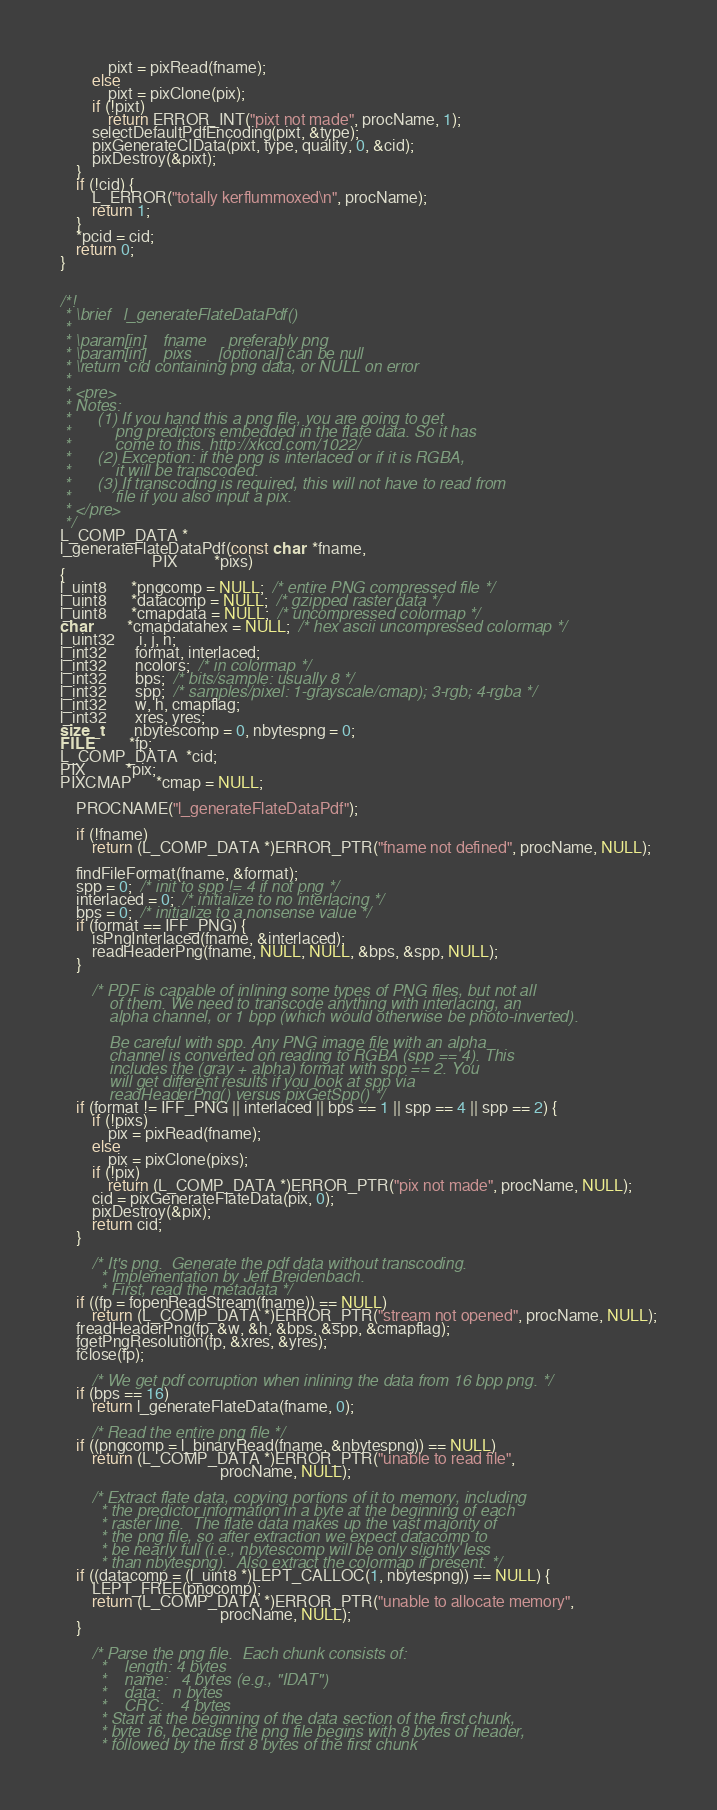Convert code to text. <code><loc_0><loc_0><loc_500><loc_500><_C_>            pixt = pixRead(fname);
        else
            pixt = pixClone(pix);
        if (!pixt)
            return ERROR_INT("pixt not made", procName, 1);
        selectDefaultPdfEncoding(pixt, &type);
        pixGenerateCIData(pixt, type, quality, 0, &cid);
        pixDestroy(&pixt);
    }
    if (!cid) {
        L_ERROR("totally kerflummoxed\n", procName);
        return 1;
    }
    *pcid = cid;
    return 0;
}


/*!
 * \brief   l_generateFlateDataPdf()
 *
 * \param[in]    fname     preferably png
 * \param[in]    pixs      [optional] can be null
 * \return  cid containing png data, or NULL on error
 *
 * <pre>
 * Notes:
 *      (1) If you hand this a png file, you are going to get
 *          png predictors embedded in the flate data. So it has
 *          come to this. http://xkcd.com/1022/
 *      (2) Exception: if the png is interlaced or if it is RGBA,
 *          it will be transcoded.
 *      (3) If transcoding is required, this will not have to read from
 *          file if you also input a pix.
 * </pre>
 */
L_COMP_DATA *
l_generateFlateDataPdf(const char  *fname,
                       PIX         *pixs)
{
l_uint8      *pngcomp = NULL;  /* entire PNG compressed file */
l_uint8      *datacomp = NULL;  /* gzipped raster data */
l_uint8      *cmapdata = NULL;  /* uncompressed colormap */
char         *cmapdatahex = NULL;  /* hex ascii uncompressed colormap */
l_uint32      i, j, n;
l_int32       format, interlaced;
l_int32       ncolors;  /* in colormap */
l_int32       bps;  /* bits/sample: usually 8 */
l_int32       spp;  /* samples/pixel: 1-grayscale/cmap); 3-rgb; 4-rgba */
l_int32       w, h, cmapflag;
l_int32       xres, yres;
size_t        nbytescomp = 0, nbytespng = 0;
FILE         *fp;
L_COMP_DATA  *cid;
PIX          *pix;
PIXCMAP      *cmap = NULL;

    PROCNAME("l_generateFlateDataPdf");

    if (!fname)
        return (L_COMP_DATA *)ERROR_PTR("fname not defined", procName, NULL);

    findFileFormat(fname, &format);
    spp = 0;  /* init to spp != 4 if not png */
    interlaced = 0;  /* initialize to no interlacing */
    bps = 0;  /* initialize to a nonsense value */
    if (format == IFF_PNG) {
        isPngInterlaced(fname, &interlaced);
        readHeaderPng(fname, NULL, NULL, &bps, &spp, NULL);
    }

        /* PDF is capable of inlining some types of PNG files, but not all
           of them. We need to transcode anything with interlacing, an
           alpha channel, or 1 bpp (which would otherwise be photo-inverted).

           Be careful with spp. Any PNG image file with an alpha
           channel is converted on reading to RGBA (spp == 4). This
           includes the (gray + alpha) format with spp == 2. You
           will get different results if you look at spp via
           readHeaderPng() versus pixGetSpp() */
    if (format != IFF_PNG || interlaced || bps == 1 || spp == 4 || spp == 2) {
        if (!pixs)
            pix = pixRead(fname);
        else
            pix = pixClone(pixs);
        if (!pix)
            return (L_COMP_DATA *)ERROR_PTR("pix not made", procName, NULL);
        cid = pixGenerateFlateData(pix, 0);
        pixDestroy(&pix);
        return cid;
    }

        /* It's png.  Generate the pdf data without transcoding.
         * Implementation by Jeff Breidenbach.
         * First, read the metadata */
    if ((fp = fopenReadStream(fname)) == NULL)
        return (L_COMP_DATA *)ERROR_PTR("stream not opened", procName, NULL);
    freadHeaderPng(fp, &w, &h, &bps, &spp, &cmapflag);
    fgetPngResolution(fp, &xres, &yres);
    fclose(fp);

        /* We get pdf corruption when inlining the data from 16 bpp png. */
    if (bps == 16)
        return l_generateFlateData(fname, 0);

        /* Read the entire png file */
    if ((pngcomp = l_binaryRead(fname, &nbytespng)) == NULL)
        return (L_COMP_DATA *)ERROR_PTR("unable to read file",
                                        procName, NULL);

        /* Extract flate data, copying portions of it to memory, including
         * the predictor information in a byte at the beginning of each
         * raster line.  The flate data makes up the vast majority of
         * the png file, so after extraction we expect datacomp to
         * be nearly full (i.e., nbytescomp will be only slightly less
         * than nbytespng).  Also extract the colormap if present. */
    if ((datacomp = (l_uint8 *)LEPT_CALLOC(1, nbytespng)) == NULL) {
        LEPT_FREE(pngcomp);
        return (L_COMP_DATA *)ERROR_PTR("unable to allocate memory",
                                        procName, NULL);
    }

        /* Parse the png file.  Each chunk consists of:
         *    length: 4 bytes
         *    name:   4 bytes (e.g., "IDAT")
         *    data:   n bytes
         *    CRC:    4 bytes
         * Start at the beginning of the data section of the first chunk,
         * byte 16, because the png file begins with 8 bytes of header,
         * followed by the first 8 bytes of the first chunk</code> 